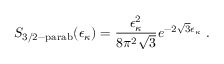<formula> <loc_0><loc_0><loc_500><loc_500>S _ { 3 / 2 - p a r a b } ( \epsilon _ { \kappa } ) = \frac { \epsilon _ { \kappa } ^ { 2 } } { 8 \pi ^ { 2 } \sqrt { 3 } } e ^ { - 2 \sqrt { 3 } \epsilon _ { \kappa } } .</formula> 